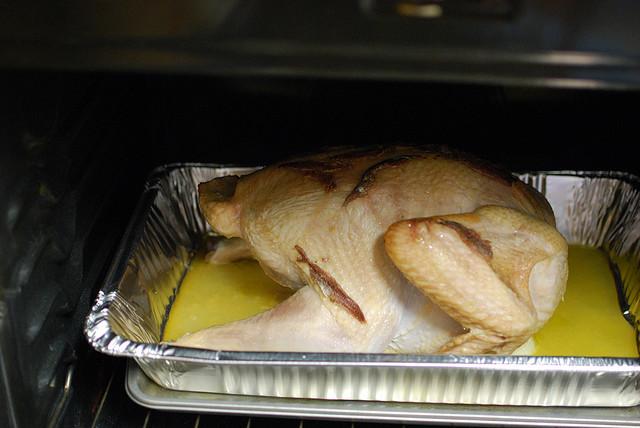What is on the foil pan?
Answer briefly. Chicken. What type of meat is being cooked?
Give a very brief answer. Chicken. Is the pan in the oven?
Quick response, please. Yes. Is this a rump roast?
Quick response, please. No. 